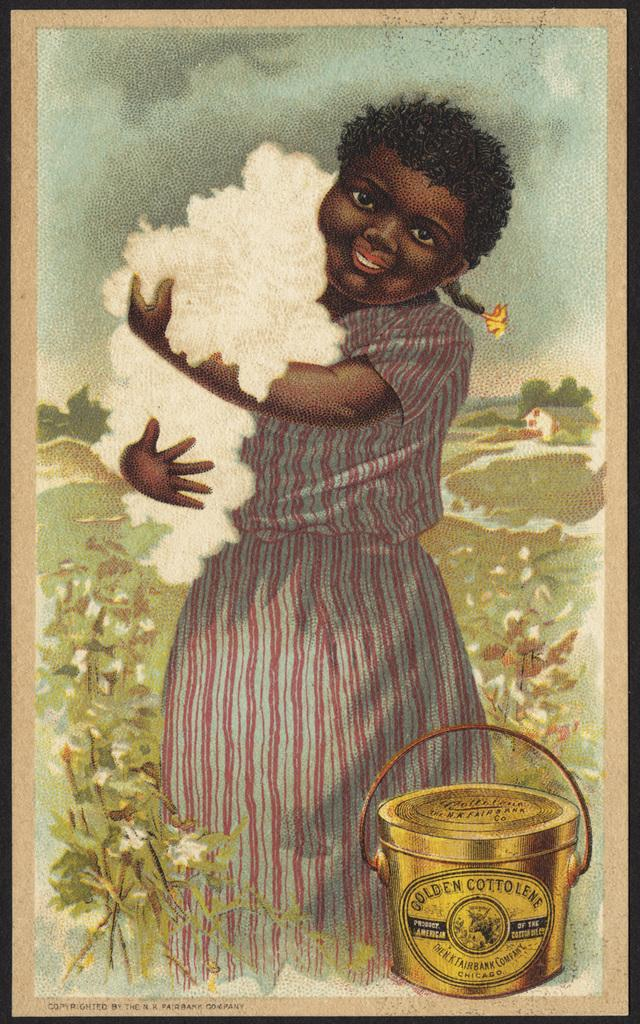<image>
Provide a brief description of the given image. a girl in a stripped dress holding golden cottonlene cotton 